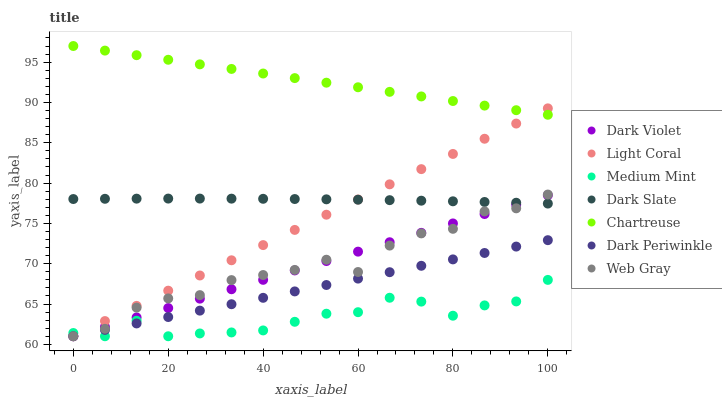Does Medium Mint have the minimum area under the curve?
Answer yes or no. Yes. Does Chartreuse have the maximum area under the curve?
Answer yes or no. Yes. Does Web Gray have the minimum area under the curve?
Answer yes or no. No. Does Web Gray have the maximum area under the curve?
Answer yes or no. No. Is Chartreuse the smoothest?
Answer yes or no. Yes. Is Web Gray the roughest?
Answer yes or no. Yes. Is Dark Violet the smoothest?
Answer yes or no. No. Is Dark Violet the roughest?
Answer yes or no. No. Does Medium Mint have the lowest value?
Answer yes or no. Yes. Does Dark Slate have the lowest value?
Answer yes or no. No. Does Chartreuse have the highest value?
Answer yes or no. Yes. Does Web Gray have the highest value?
Answer yes or no. No. Is Web Gray less than Chartreuse?
Answer yes or no. Yes. Is Chartreuse greater than Web Gray?
Answer yes or no. Yes. Does Light Coral intersect Medium Mint?
Answer yes or no. Yes. Is Light Coral less than Medium Mint?
Answer yes or no. No. Is Light Coral greater than Medium Mint?
Answer yes or no. No. Does Web Gray intersect Chartreuse?
Answer yes or no. No. 